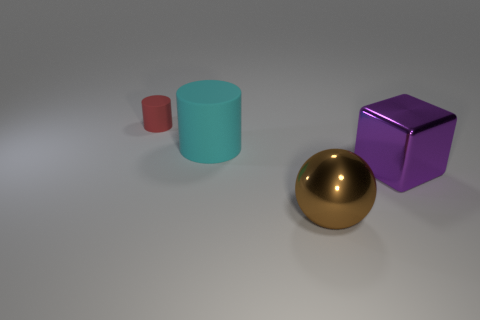The small matte object that is the same shape as the big cyan matte object is what color?
Your response must be concise. Red. What number of spheres have the same color as the large matte cylinder?
Provide a succinct answer. 0. The matte cylinder left of the cylinder that is in front of the cylinder that is on the left side of the big cyan thing is what color?
Your answer should be compact. Red. Is the material of the ball the same as the cyan thing?
Provide a succinct answer. No. Does the red thing have the same shape as the large purple object?
Give a very brief answer. No. Are there an equal number of large cyan rubber cylinders in front of the cyan rubber object and brown spheres on the right side of the brown ball?
Keep it short and to the point. Yes. The cube that is made of the same material as the big brown sphere is what color?
Your response must be concise. Purple. How many purple things are made of the same material as the block?
Provide a succinct answer. 0. Does the metallic object behind the large brown metal object have the same color as the big rubber object?
Your answer should be compact. No. What number of big cyan things are the same shape as the tiny red object?
Provide a succinct answer. 1. 